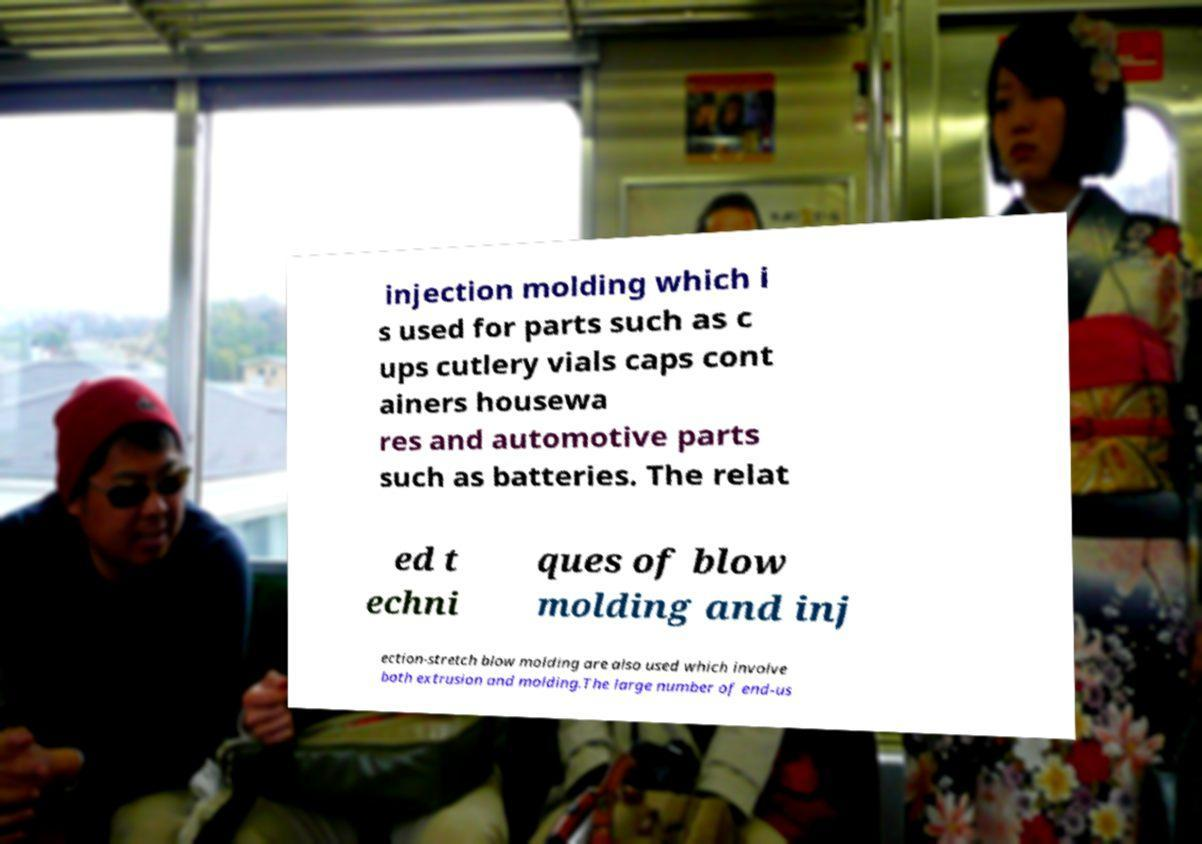What messages or text are displayed in this image? I need them in a readable, typed format. injection molding which i s used for parts such as c ups cutlery vials caps cont ainers housewa res and automotive parts such as batteries. The relat ed t echni ques of blow molding and inj ection-stretch blow molding are also used which involve both extrusion and molding.The large number of end-us 